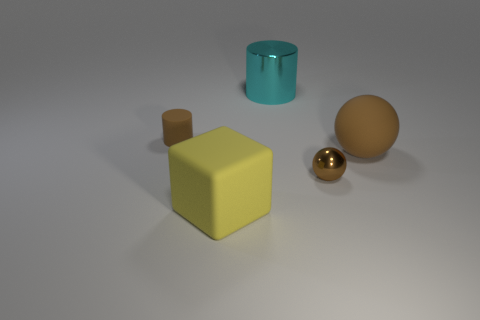Add 5 big green blocks. How many objects exist? 10 Subtract 1 brown cylinders. How many objects are left? 4 Subtract all cylinders. How many objects are left? 3 Subtract all tiny brown matte cubes. Subtract all large rubber objects. How many objects are left? 3 Add 2 brown rubber cylinders. How many brown rubber cylinders are left? 3 Add 1 tiny red balls. How many tiny red balls exist? 1 